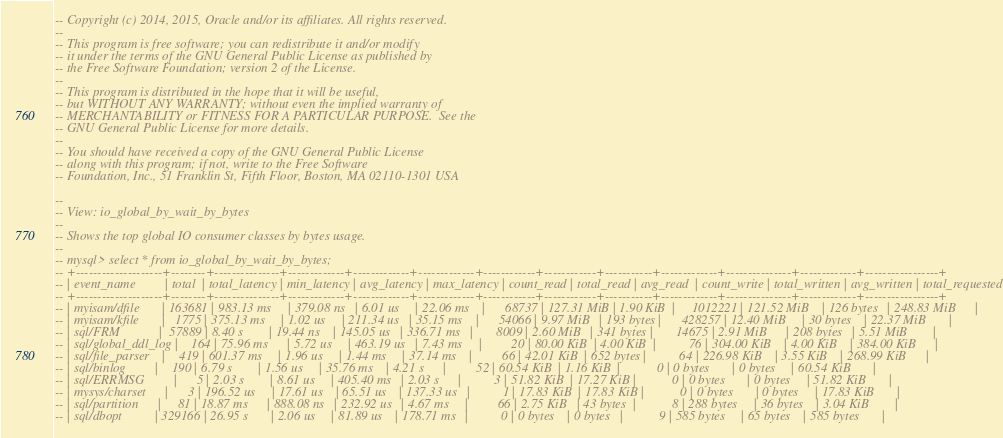<code> <loc_0><loc_0><loc_500><loc_500><_SQL_>-- Copyright (c) 2014, 2015, Oracle and/or its affiliates. All rights reserved.
--
-- This program is free software; you can redistribute it and/or modify
-- it under the terms of the GNU General Public License as published by
-- the Free Software Foundation; version 2 of the License.
--
-- This program is distributed in the hope that it will be useful,
-- but WITHOUT ANY WARRANTY; without even the implied warranty of
-- MERCHANTABILITY or FITNESS FOR A PARTICULAR PURPOSE.  See the
-- GNU General Public License for more details.
--
-- You should have received a copy of the GNU General Public License
-- along with this program; if not, write to the Free Software
-- Foundation, Inc., 51 Franklin St, Fifth Floor, Boston, MA 02110-1301 USA

--
-- View: io_global_by_wait_by_bytes
--
-- Shows the top global IO consumer classes by bytes usage.
--
-- mysql> select * from io_global_by_wait_by_bytes;
-- +--------------------+--------+---------------+-------------+-------------+-------------+------------+------------+-----------+-------------+---------------+-------------+-----------------+
-- | event_name         | total  | total_latency | min_latency | avg_latency | max_latency | count_read | total_read | avg_read  | count_write | total_written | avg_written | total_requested |
-- +--------------------+--------+---------------+-------------+-------------+-------------+------------+------------+-----------+-------------+---------------+-------------+-----------------+
-- | myisam/dfile       | 163681 | 983.13 ms     | 379.08 ns   | 6.01 us     | 22.06 ms    |      68737 | 127.31 MiB | 1.90 KiB  |     1012221 | 121.52 MiB    | 126 bytes   | 248.83 MiB      |
-- | myisam/kfile       |   1775 | 375.13 ms     | 1.02 us     | 211.34 us   | 35.15 ms    |      54066 | 9.97 MiB   | 193 bytes |      428257 | 12.40 MiB     | 30 bytes    | 22.37 MiB       |
-- | sql/FRM            |  57889 | 8.40 s        | 19.44 ns    | 145.05 us   | 336.71 ms   |       8009 | 2.60 MiB   | 341 bytes |       14675 | 2.91 MiB      | 208 bytes   | 5.51 MiB        |
-- | sql/global_ddl_log |    164 | 75.96 ms      | 5.72 us     | 463.19 us   | 7.43 ms     |         20 | 80.00 KiB  | 4.00 KiB  |          76 | 304.00 KiB    | 4.00 KiB    | 384.00 KiB      |
-- | sql/file_parser    |    419 | 601.37 ms     | 1.96 us     | 1.44 ms     | 37.14 ms    |         66 | 42.01 KiB  | 652 bytes |          64 | 226.98 KiB    | 3.55 KiB    | 268.99 KiB      |
-- | sql/binlog         |    190 | 6.79 s        | 1.56 us     | 35.76 ms    | 4.21 s      |         52 | 60.54 KiB  | 1.16 KiB  |           0 | 0 bytes       | 0 bytes     | 60.54 KiB       |
-- | sql/ERRMSG         |      5 | 2.03 s        | 8.61 us     | 405.40 ms   | 2.03 s      |          3 | 51.82 KiB  | 17.27 KiB |           0 | 0 bytes       | 0 bytes     | 51.82 KiB       |
-- | mysys/charset      |      3 | 196.52 us     | 17.61 us    | 65.51 us    | 137.33 us   |          1 | 17.83 KiB  | 17.83 KiB |           0 | 0 bytes       | 0 bytes     | 17.83 KiB       |
-- | sql/partition      |     81 | 18.87 ms      | 888.08 ns   | 232.92 us   | 4.67 ms     |         66 | 2.75 KiB   | 43 bytes  |           8 | 288 bytes     | 36 bytes    | 3.04 KiB        |
-- | sql/dbopt          | 329166 | 26.95 s       | 2.06 us     | 81.89 us    | 178.71 ms   |          0 | 0 bytes    | 0 bytes   |           9 | 585 bytes     | 65 bytes    | 585 bytes       |</code> 